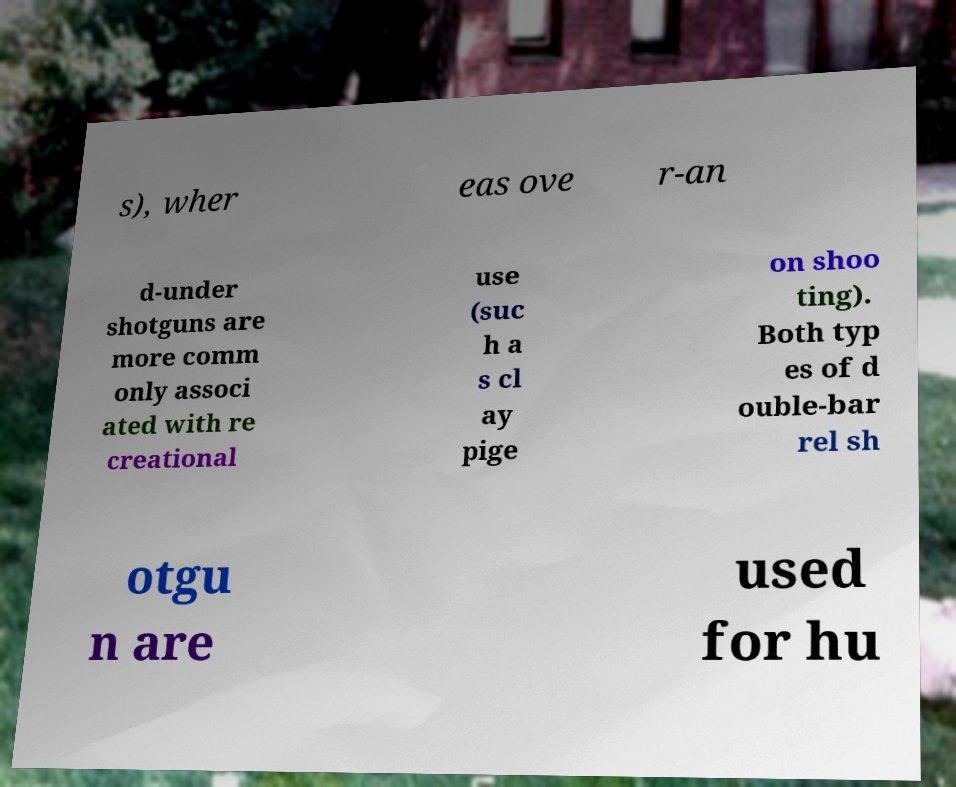Can you accurately transcribe the text from the provided image for me? s), wher eas ove r-an d-under shotguns are more comm only associ ated with re creational use (suc h a s cl ay pige on shoo ting). Both typ es of d ouble-bar rel sh otgu n are used for hu 